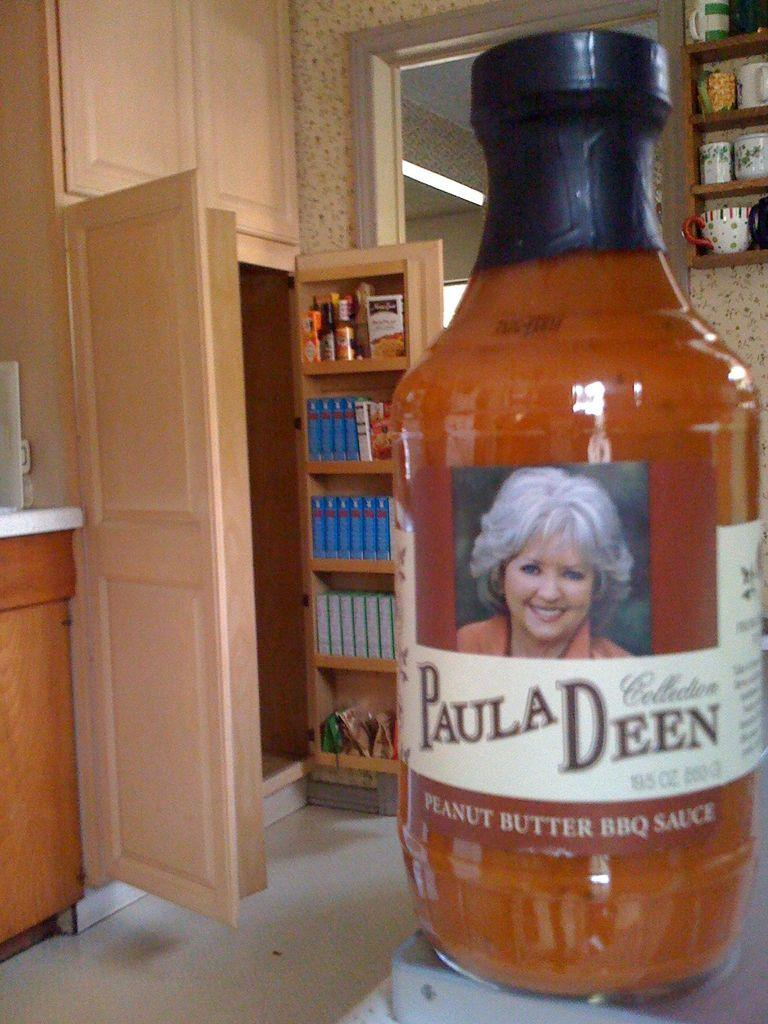Provide a one-sentence caption for the provided image. A bottle of Paula Deen Peanut Butter BBQ Sauce sits on the counter in a kitchen. 